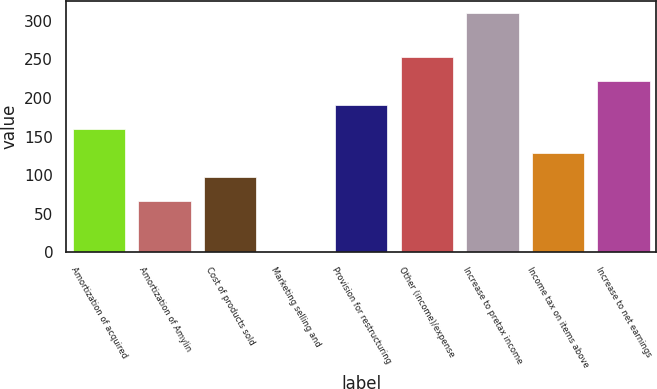Convert chart to OTSL. <chart><loc_0><loc_0><loc_500><loc_500><bar_chart><fcel>Amortization of acquired<fcel>Amortization of Amylin<fcel>Cost of products sold<fcel>Marketing selling and<fcel>Provision for restructuring<fcel>Other (income)/expense<fcel>Increase to pretax income<fcel>Income tax on items above<fcel>Increase to net earnings<nl><fcel>159.7<fcel>67<fcel>97.9<fcel>1<fcel>190.6<fcel>252.4<fcel>310<fcel>128.8<fcel>221.5<nl></chart> 